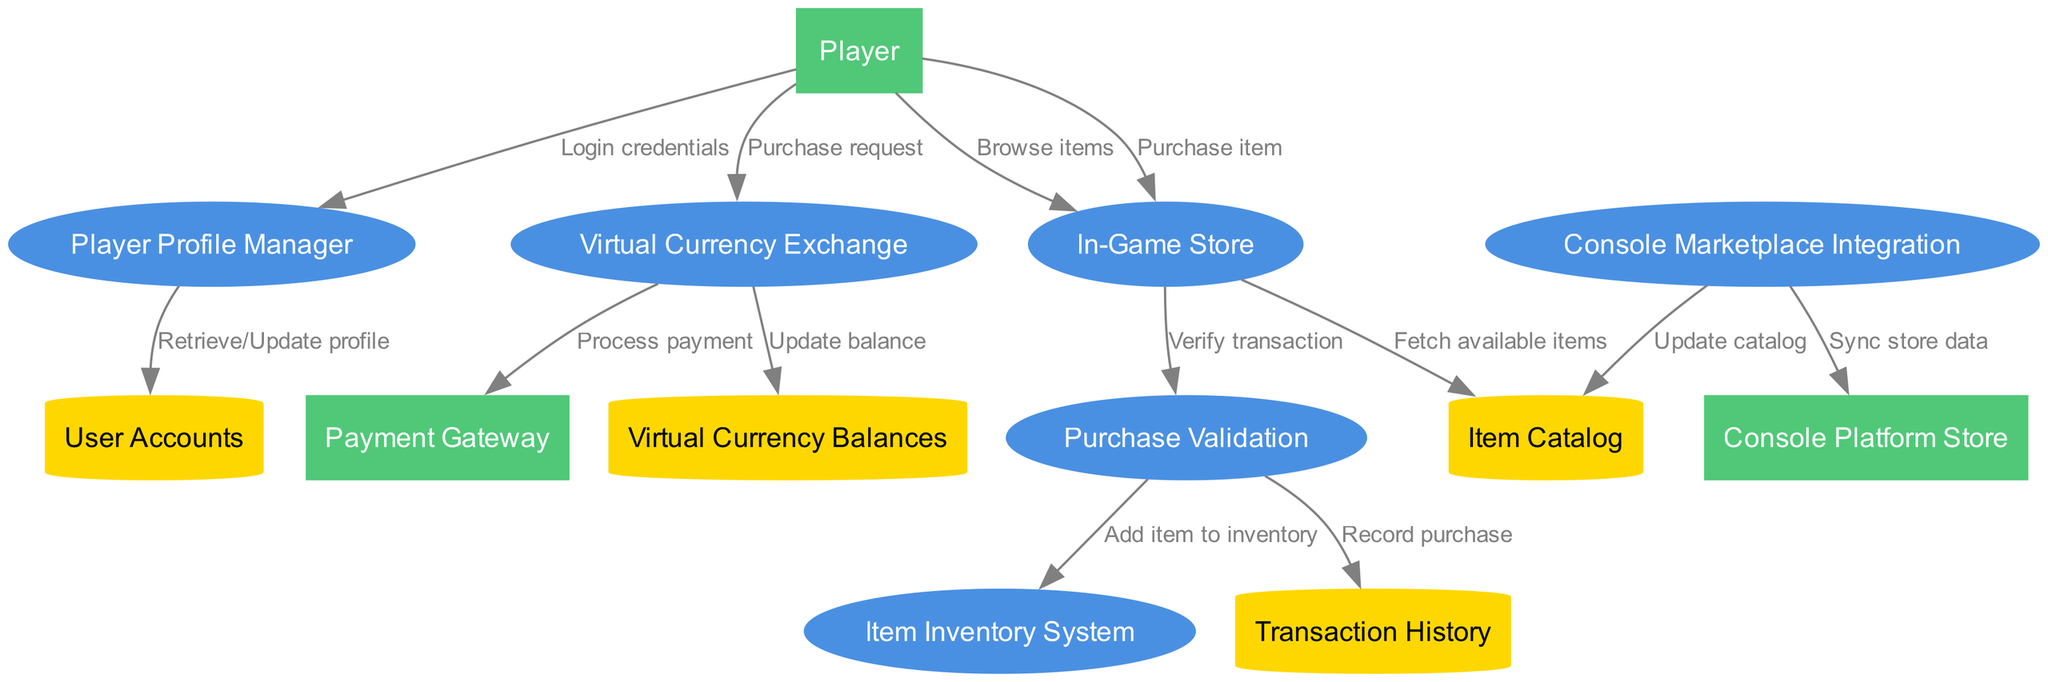What is the total number of processes in the diagram? There are 6 processes listed in the diagram: Player Profile Manager, Virtual Currency Exchange, In-Game Store, Item Inventory System, Purchase Validation, and Console Marketplace Integration.
Answer: 6 Which external entity interacts with the Payment Gateway? The Payment Gateway receives payment processing requests from the Virtual Currency Exchange, which is initiated by the Player. The only external entity in this interaction is the Payment Gateway.
Answer: Payment Gateway What type of data store is the User Accounts? User Accounts is labeled as a data store in the diagram which is represented as a cylinder. In this context, all data stores are displayed this way, indicating that they hold data used by the processes.
Answer: Cylinder Which process is responsible for adding items to the player's inventory? The process that adds items to the inventory is Purchase Validation, which receives confirmation to add an item to the Item Inventory System upon successful purchase verification.
Answer: Purchase Validation What is the flow direction from the Virtual Currency Exchange to the Virtual Currency Balances? The flow from the Virtual Currency Exchange to the Virtual Currency Balances indicates an update in balance after a currency purchase has been processed. This flow signifies the transfer of data regarding the updated balance.
Answer: Update balance Which external entity is directly connected to the Console Marketplace Integration? The Console Marketplace Integration is connected to the Console Platform Store, and it is responsible for syncing store data with external entities directly related to the console ecosystem.
Answer: Console Platform Store How many data stores are present in the diagram? The diagram contains 4 data stores which include User Accounts, Transaction History, Item Catalog, and Virtual Currency Balances.
Answer: 4 Which process fetches available items from the Item Catalog? The In-Game Store process is responsible for fetching the list of available items from the Item Catalog when a player browses items. This flow is essential for displaying items to the player.
Answer: In-Game Store What is the purpose of the flow labeled "Record purchase"? The flow labeled "Record purchase" signifies that the Purchase Validation process writes a record of each completed transaction into the Transaction History data store, maintaining a record of player purchases.
Answer: Record purchase 